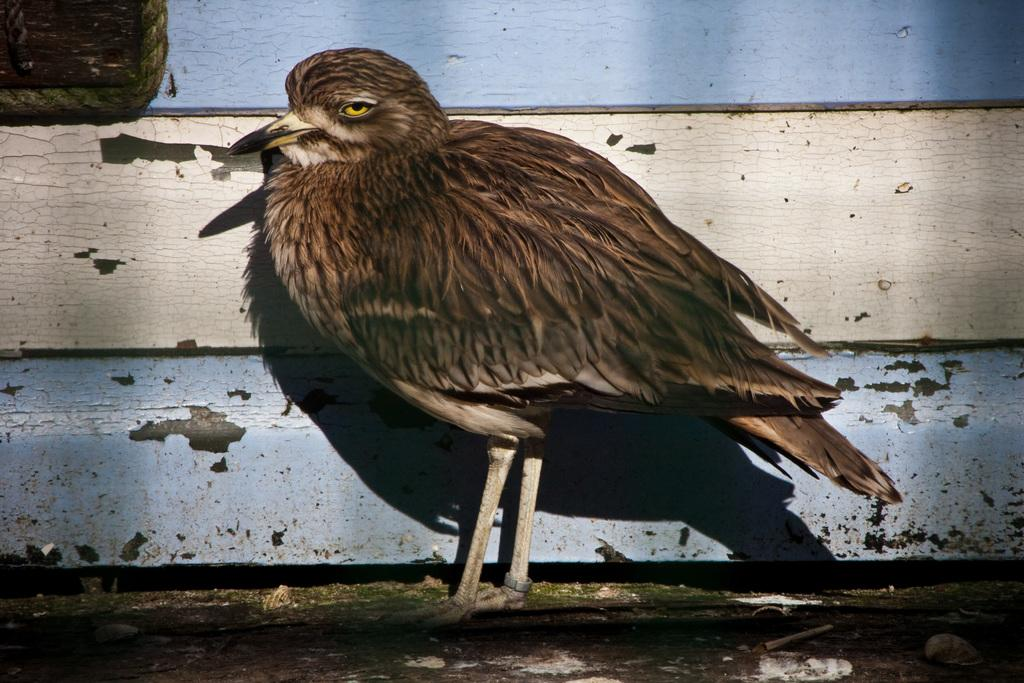What type of animal is in the image? There is a bird in the image. What color is the bird? The bird is brown in color. What colors are present in the background of the image? The background of the image is blue and cream in color. What letter is the bird holding in its beak in the image? There is no letter present in the image, and the bird is not holding anything in its beak. 